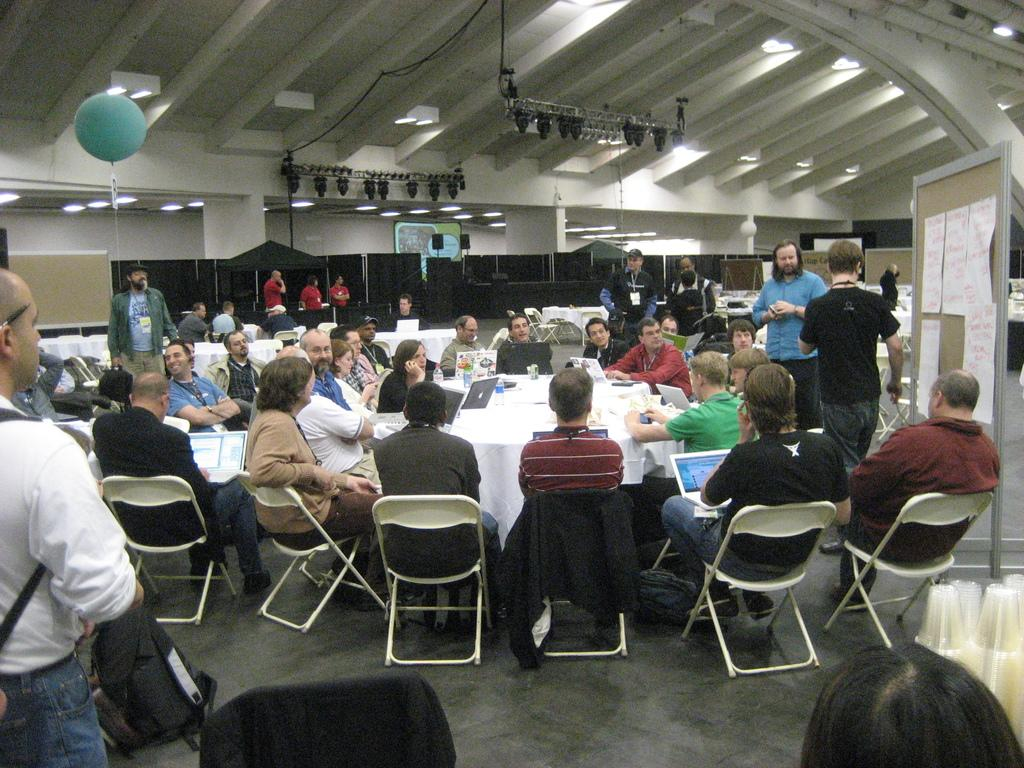What is happening in the image involving the group of people? There is a group of people sitting around a table, and they are listening to a man. Can you describe the setting in which this is happening? The people are sitting around a table, which suggests they might be in a meeting or discussion setting. Are there any other people present besides those sitting at the table? Yes, there are other people standing around. What type of toad can be seen sitting on the table in the image? There is no toad present in the image; it features a group of people sitting around a table and listening to a man. What time of day is it in the image, given the presence of the morning sun? There is no mention of the time of day or the presence of the morning sun in the image. 